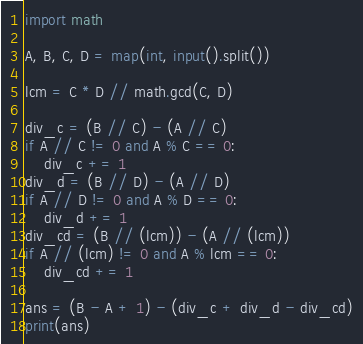<code> <loc_0><loc_0><loc_500><loc_500><_Python_>import math

A, B, C, D = map(int, input().split())

lcm = C * D // math.gcd(C, D)

div_c = (B // C) - (A // C)
if A // C != 0 and A % C == 0:
    div_c += 1
div_d = (B // D) - (A // D)
if A // D != 0 and A % D == 0:
    div_d += 1
div_cd = (B // (lcm)) - (A // (lcm))
if A // (lcm) != 0 and A % lcm == 0:
    div_cd += 1

ans = (B - A + 1) - (div_c + div_d - div_cd)
print(ans)</code> 